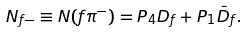<formula> <loc_0><loc_0><loc_500><loc_500>N _ { f - } \equiv N ( f \pi ^ { - } ) = P _ { 4 } D _ { f } + P _ { 1 } \bar { D } _ { f } .</formula> 